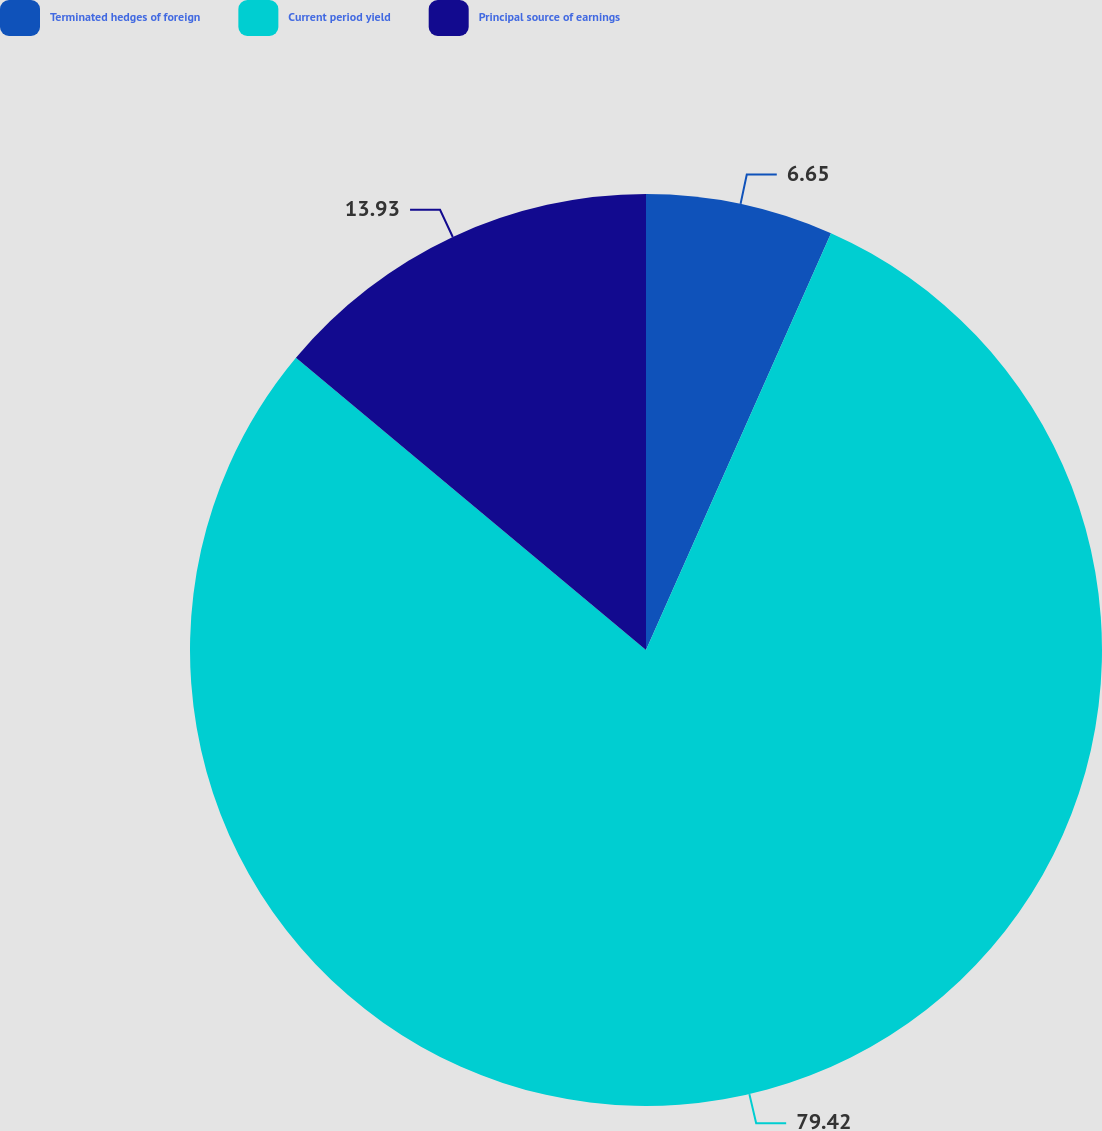Convert chart to OTSL. <chart><loc_0><loc_0><loc_500><loc_500><pie_chart><fcel>Terminated hedges of foreign<fcel>Current period yield<fcel>Principal source of earnings<nl><fcel>6.65%<fcel>79.43%<fcel>13.93%<nl></chart> 